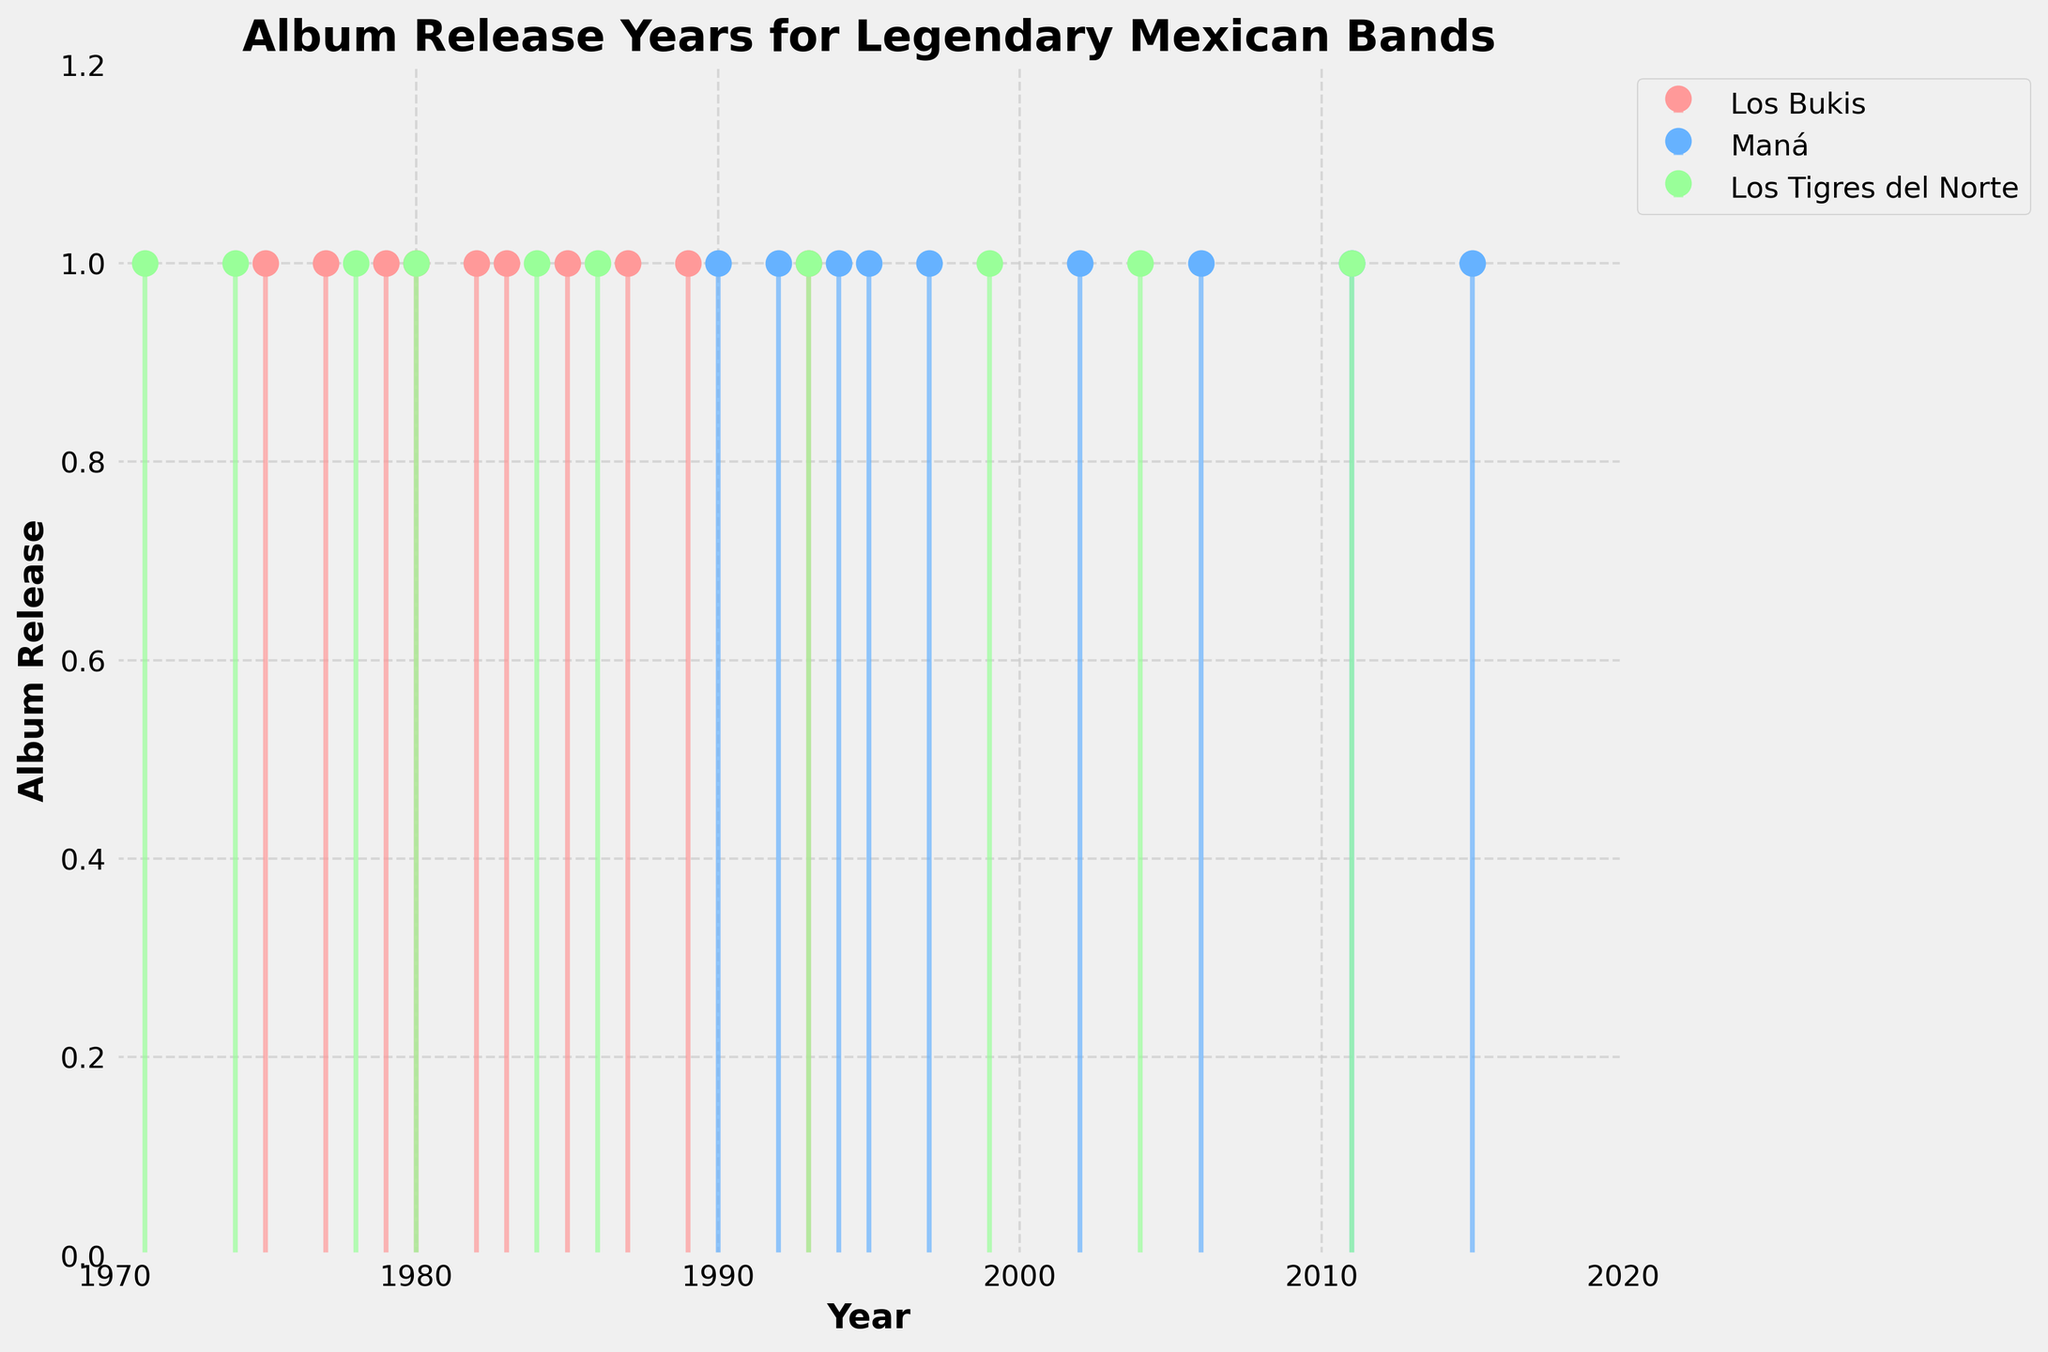What is the title of the figure? The title of the figure is located at the top of the plot and provides a summary of what the plot represents.
Answer: Album Release Years for Legendary Mexican Bands What is the range of years shown on the x-axis? The x-axis labels the time period represented in the plot, showing the minimum and maximum values.
Answer: 1970 to 2020 Which band has the earliest album release? By looking at the leftmost data points on the plot, we can see which band released an album the earliest.
Answer: Los Tigres del Norte How many albums did Los Bukis release in the 1980s? Count the number of data points for Los Bukis that fall within the range 1980-1989.
Answer: Five Which bands released albums in the year 1993? Check for data points at the year 1993 and note the corresponding bands.
Answer: Los Bukis and Los Tigres del Norte Who released more albums in the 1990s, Maná or Los Tigres del Norte? Count the number of data points for each band within the years 1990-1999 and compare the totals.
Answer: Maná How does the number of albums released by Los Bukis in the 1980s compare to the number released by Maná in the 2000s? Count the number of albums released by each band in the specified decades and compare.
Answer: Los Bukis: 5, Maná: 3, Los Bukis released more What colors represent each band on the plot? Identify the colors used for each band's data points and lines.
Answer: Los Bukis: Red, Maná: Blue, Los Tigres del Norte: Green How many albums did Los Tigres del Norte release in total? Count the total number of data points for Los Tigres del Norte on the plot.
Answer: Ten Which band has the most consistently spaced album releases over time? Look at the spacing between each band's data points on the plot to determine which has the most regular intervals.
Answer: Maná 